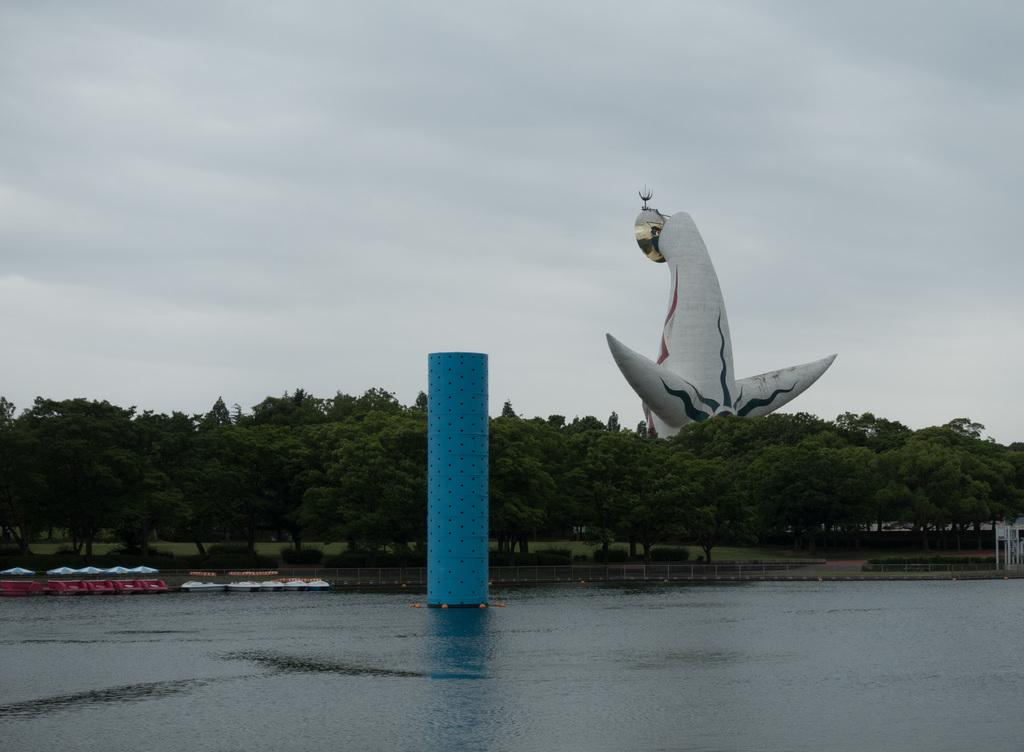What is the main object in the center of the image? There is an object in the center of the image, and it is blue in color. What can be seen in the background of the image? There are trees and a sculpture in the background of the image. What is present at the bottom of the image? There is water at the bottom of the image. Reasoning: Let'g: Let's think step by step in order to produce the conversation. We start by identifying the main object in the image, which is the blue object in the center. Then, we describe the background, mentioning the trees and the sculpture. Finally, we focus on the bottom of the image, where water is present. Each question is designed to elicit a specific detail about the image that is known from the provided facts. Absurd Question/Answer: What type of pump is being used to play the guitar in the image? There is no pump or guitar present in the image. Is the coat visible in the image? There is no coat present in the image. What type of pump is being used to play the guitar in the image? There is no pump or guitar present in the image. Is the coat visible in the image? There is no coat present in the image. 